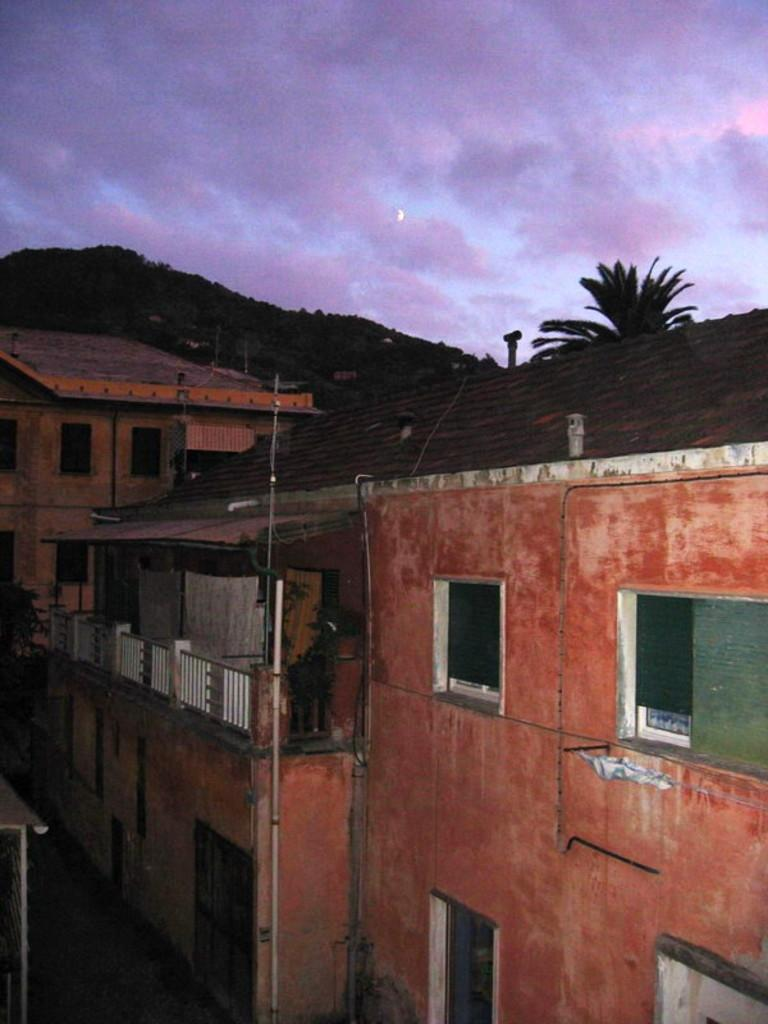What type of structures can be seen in the image? There are buildings in the image. What other natural elements are present in the image? There are trees and a mountain with trees in the image. What is visible in the background of the image? The sky is visible in the image. What can be seen in the sky? Clouds are present in the sky. What type of riddle can be solved by finding the key in the image? There is no riddle or key present in the image; it features buildings, trees, a mountain, and clouds. Can you tell me how many wounds are visible on the trees in the image? There are no wounds visible on the trees in the image; they appear to be healthy and intact. 